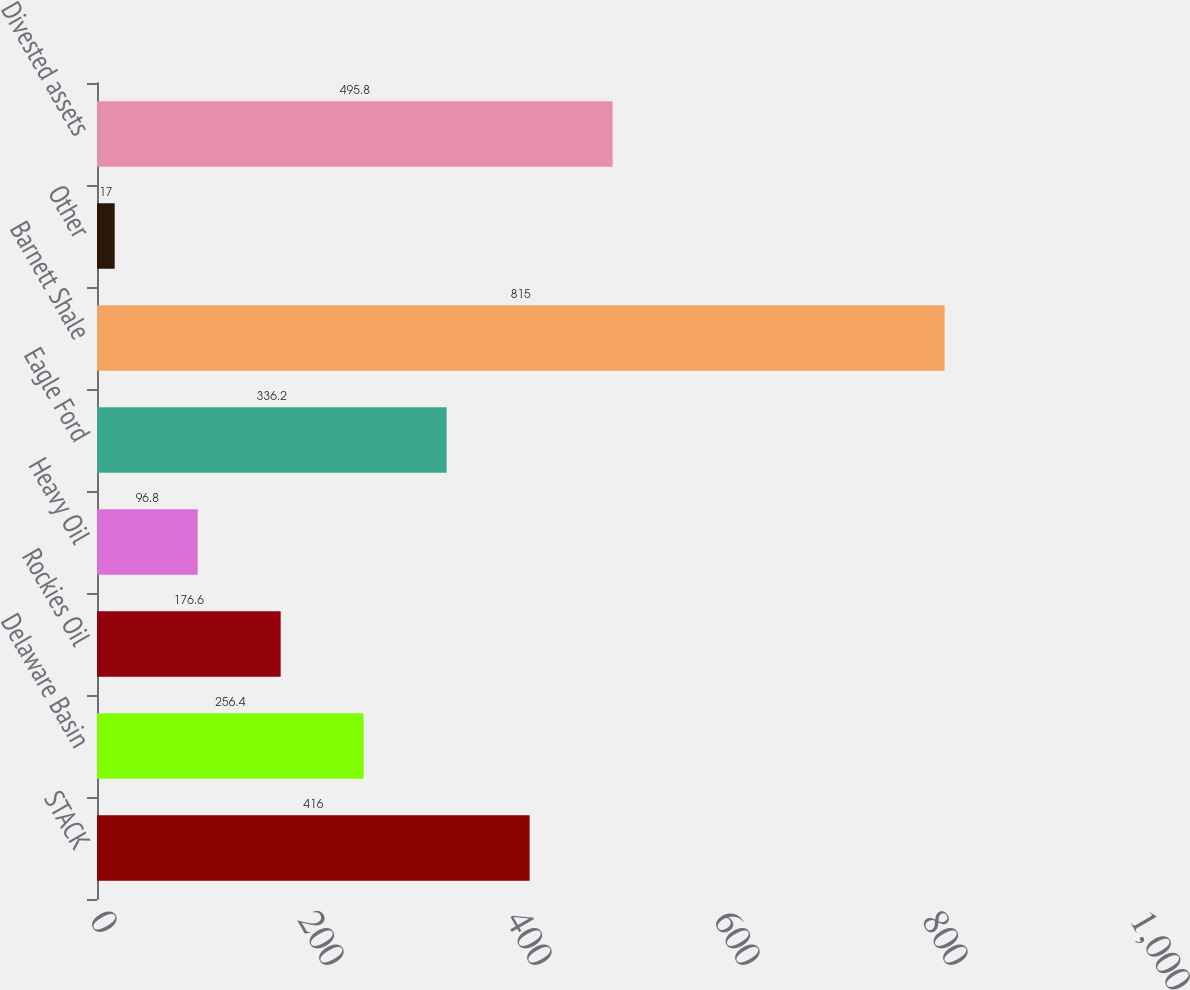<chart> <loc_0><loc_0><loc_500><loc_500><bar_chart><fcel>STACK<fcel>Delaware Basin<fcel>Rockies Oil<fcel>Heavy Oil<fcel>Eagle Ford<fcel>Barnett Shale<fcel>Other<fcel>Divested assets<nl><fcel>416<fcel>256.4<fcel>176.6<fcel>96.8<fcel>336.2<fcel>815<fcel>17<fcel>495.8<nl></chart> 